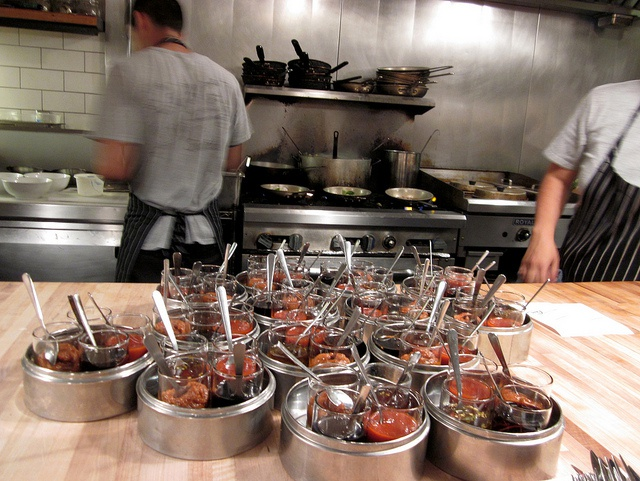Describe the objects in this image and their specific colors. I can see dining table in black, white, tan, and gray tones, cup in black, gray, and maroon tones, people in black, gray, and darkgray tones, spoon in black, gray, and darkgray tones, and people in black, lightgray, darkgray, and gray tones in this image. 